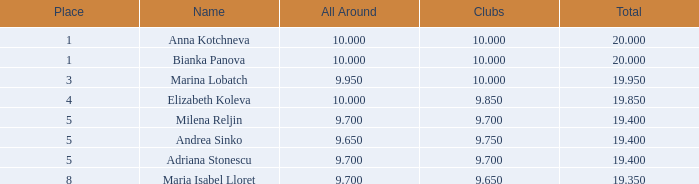In how many locations is bianka panova's name associated with clubs having fewer than 10 members? 0.0. 